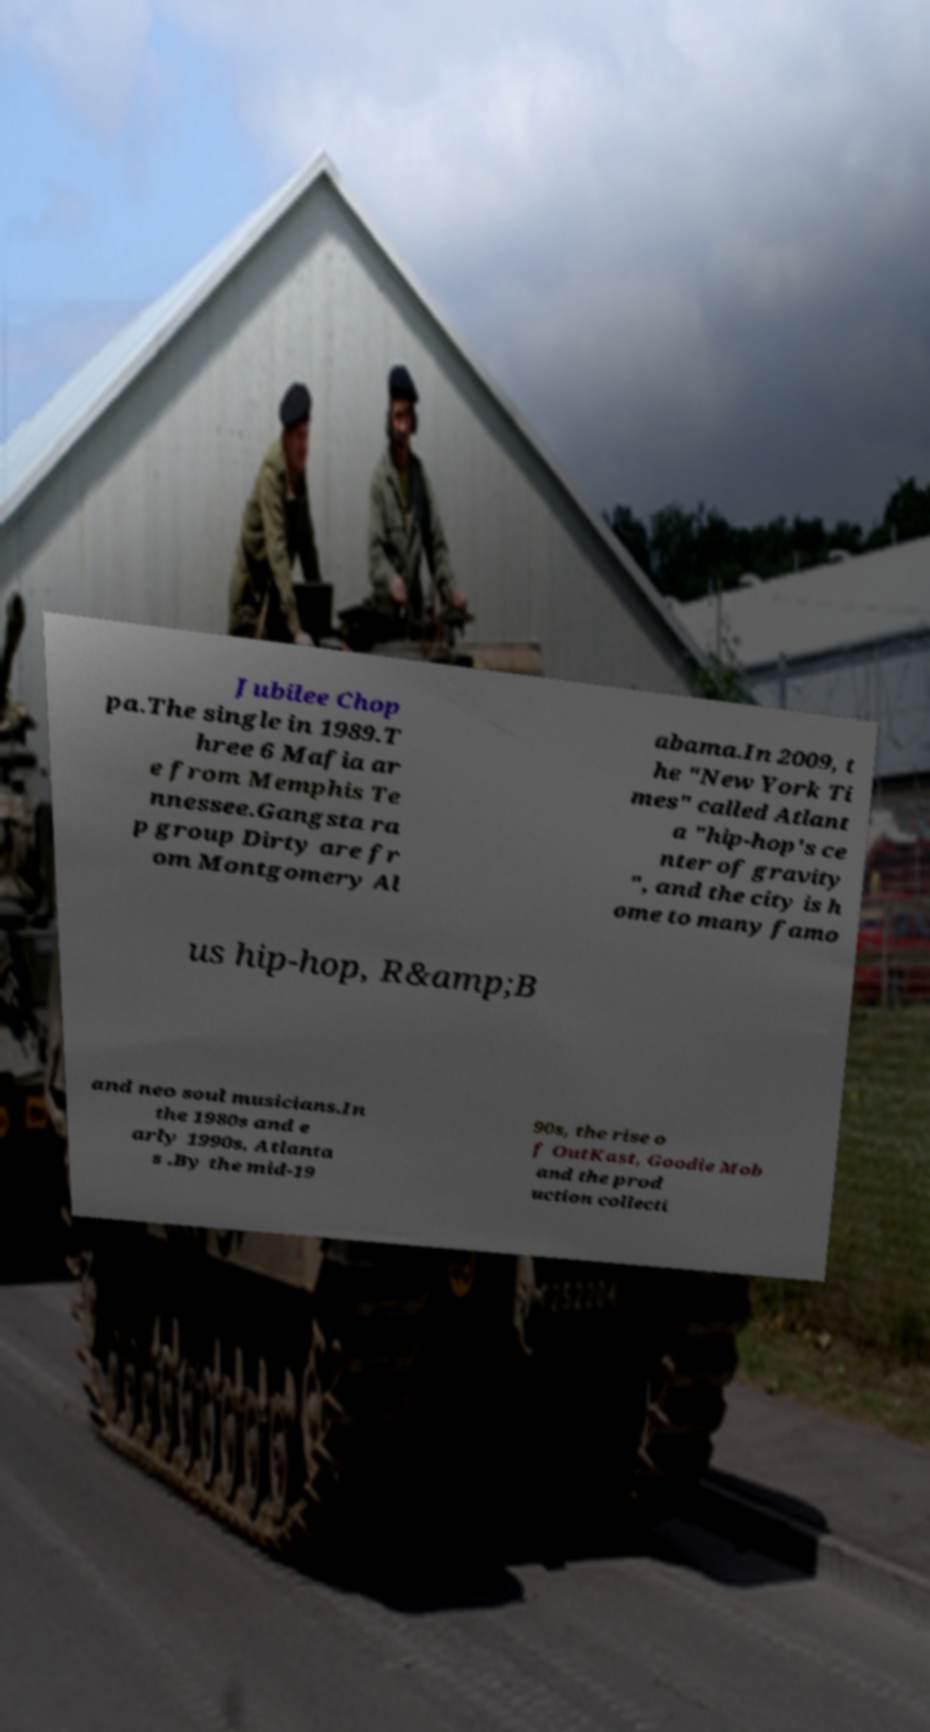Please read and relay the text visible in this image. What does it say? Jubilee Chop pa.The single in 1989.T hree 6 Mafia ar e from Memphis Te nnessee.Gangsta ra p group Dirty are fr om Montgomery Al abama.In 2009, t he "New York Ti mes" called Atlant a "hip-hop's ce nter of gravity ", and the city is h ome to many famo us hip-hop, R&amp;B and neo soul musicians.In the 1980s and e arly 1990s, Atlanta s .By the mid-19 90s, the rise o f OutKast, Goodie Mob and the prod uction collecti 